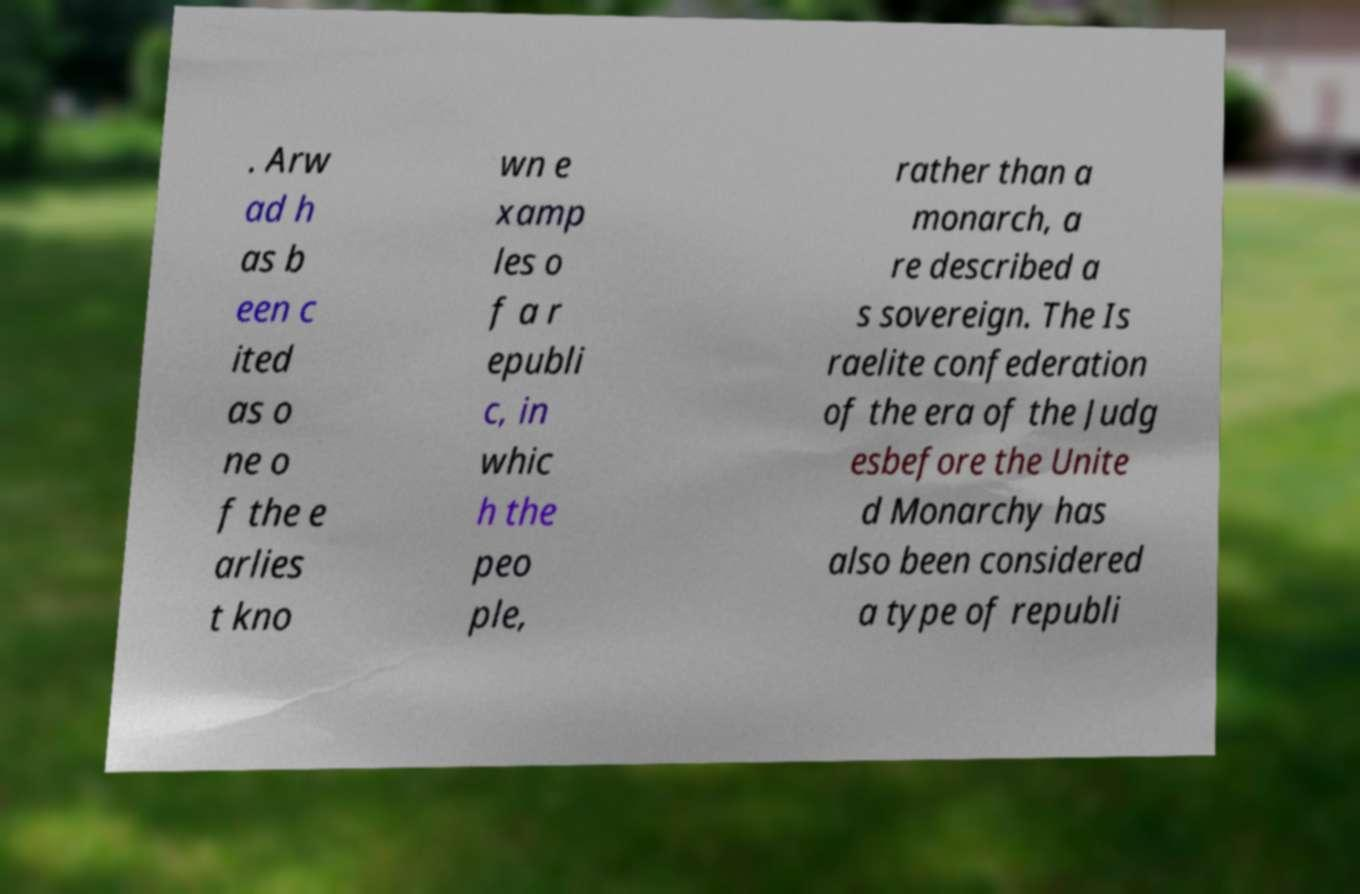Please identify and transcribe the text found in this image. . Arw ad h as b een c ited as o ne o f the e arlies t kno wn e xamp les o f a r epubli c, in whic h the peo ple, rather than a monarch, a re described a s sovereign. The Is raelite confederation of the era of the Judg esbefore the Unite d Monarchy has also been considered a type of republi 